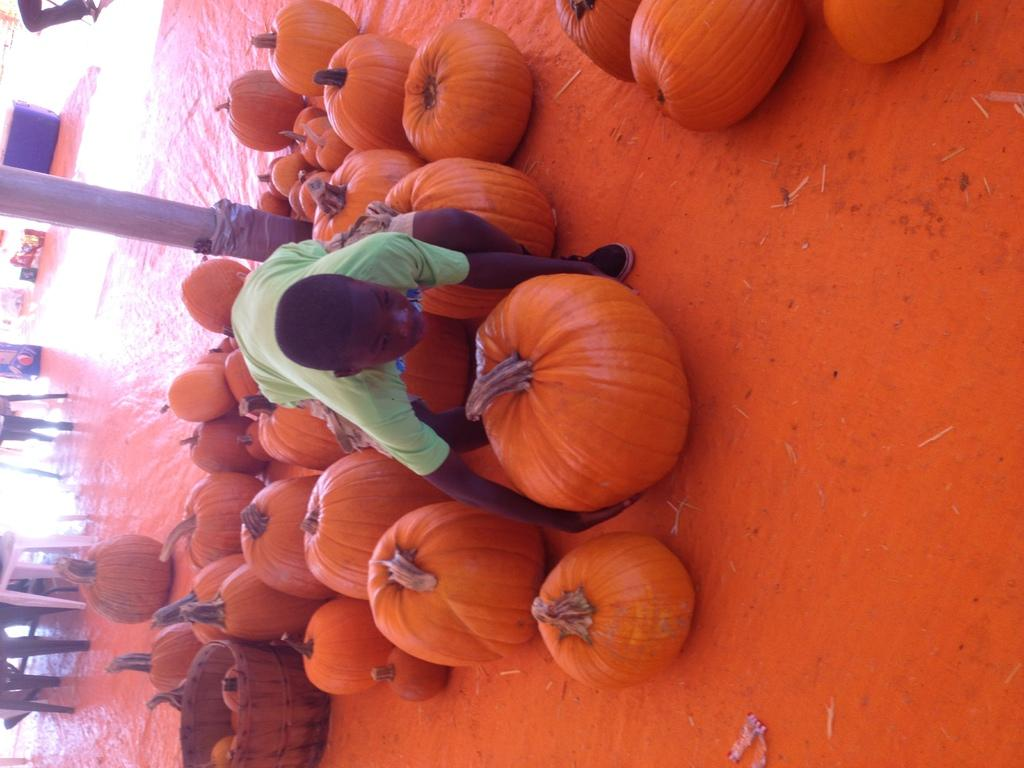What type of vegetable is not present in the image? There is no cabbage present in the image. What color are the pumpkins in the image? The pumpkins in the image are orange-colored. What object can be used for holding or storing items in the image? There is a container in the image that can be used for holding or storing items. What type of furniture is present in the image? There are chairs in the image. What is the person in the image wearing? The person in the image is wearing a green-colored dress. What type of rail can be seen in the image? A: There is no rail present in the image. 